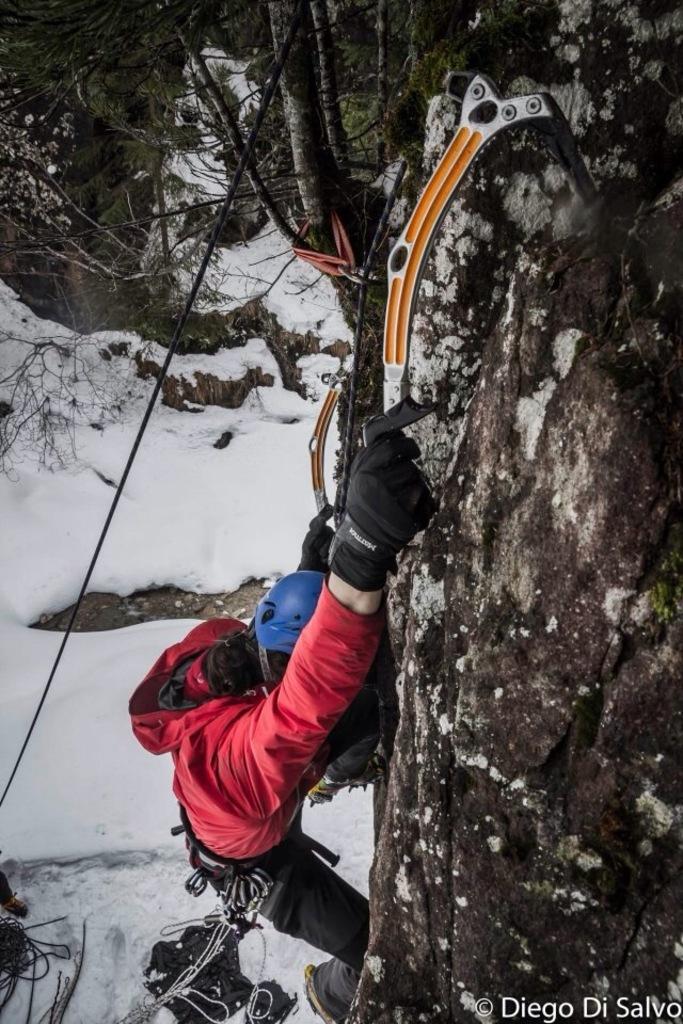How would you summarize this image in a sentence or two? In this picture there is a man who is wearing helmet, jacket, gloves and shoe. He is holding snow hammer. In the background i can see many trees and snow. In the bottom right corner there is a watermark. At the top i can see many trees. On the left there is a black rope. 